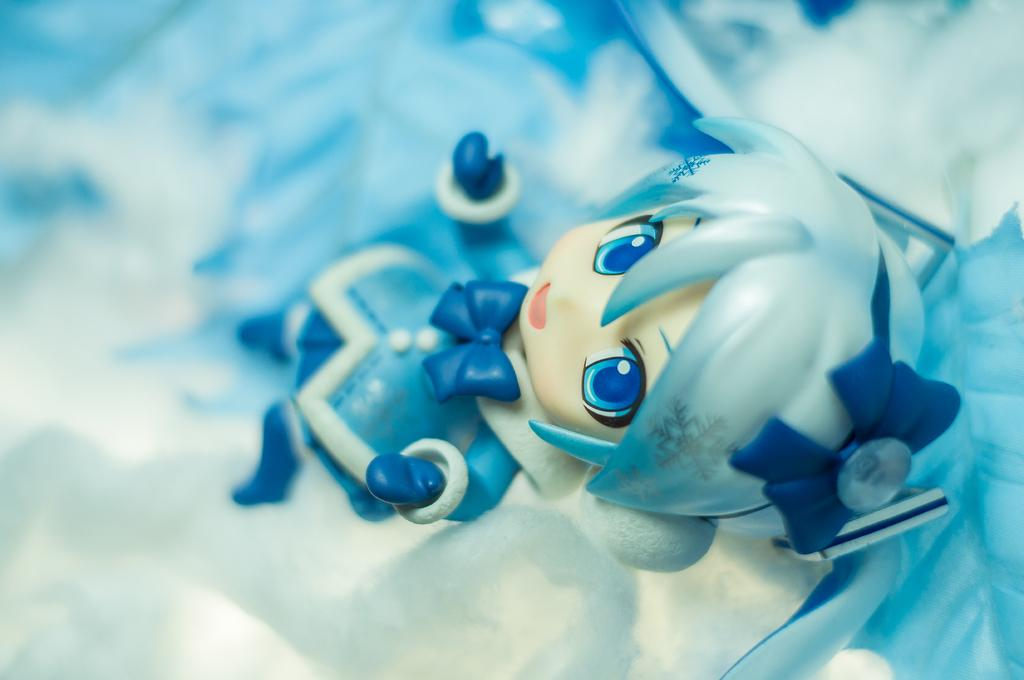What object can be seen in the image? There is a toy in the image. Can you describe the background of the image? The background of the image is blurred. What type of fang is visible on the toy in the image? There is no fang visible on the toy in the image. How many channels can be seen on the toy in the image? There are no channels present on the toy in the image. 